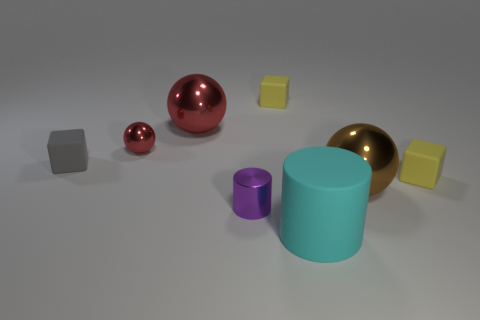There is a yellow block to the left of the brown thing; what is its size?
Your answer should be compact. Small. What is the size of the brown thing that is the same material as the purple thing?
Keep it short and to the point. Large. How many things are the same color as the tiny metal cylinder?
Your answer should be compact. 0. Is there a large brown sphere?
Give a very brief answer. Yes. There is a large red thing; does it have the same shape as the red thing in front of the large red thing?
Offer a terse response. Yes. What color is the tiny matte block in front of the small rubber object that is on the left side of the metallic cylinder that is on the left side of the brown ball?
Your answer should be compact. Yellow. Are there any big brown shiny balls in front of the metal cylinder?
Your response must be concise. No. What is the size of the object that is the same color as the small sphere?
Keep it short and to the point. Large. Is there a small yellow cube that has the same material as the purple cylinder?
Make the answer very short. No. What color is the big cylinder?
Provide a succinct answer. Cyan. 